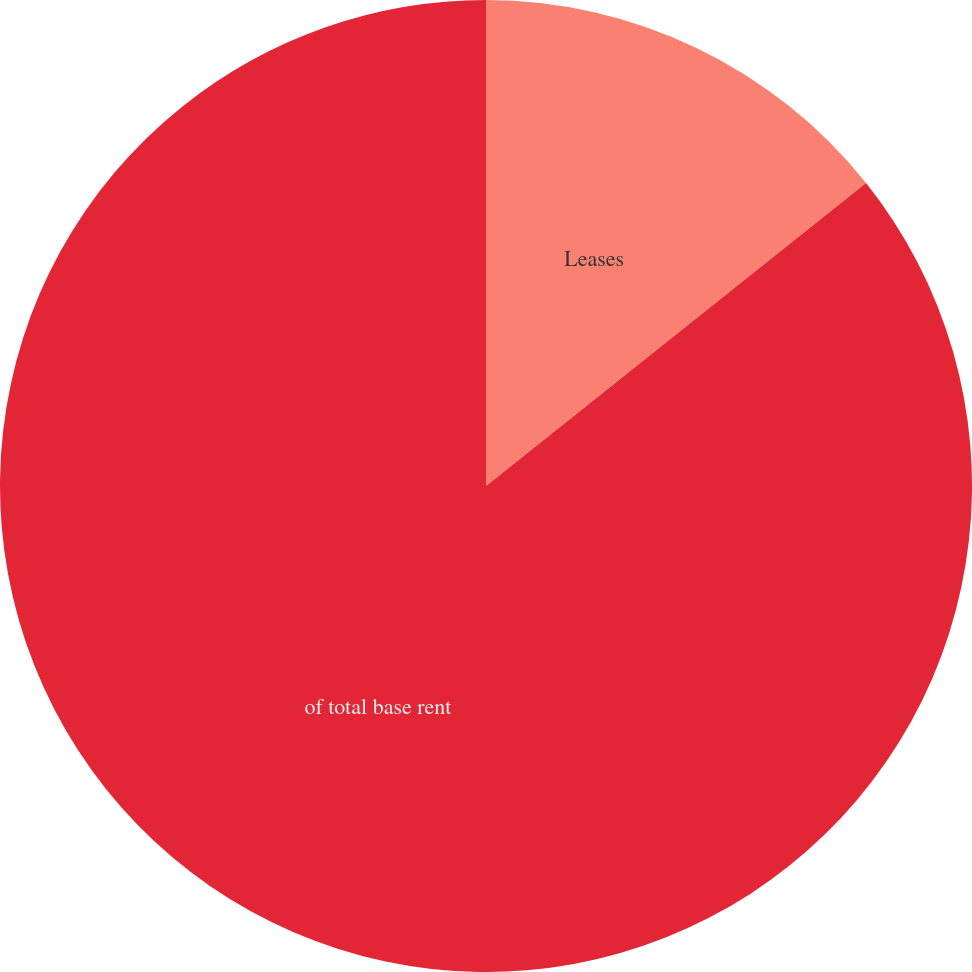Convert chart. <chart><loc_0><loc_0><loc_500><loc_500><pie_chart><fcel>Leases<fcel>of total base rent<nl><fcel>14.29%<fcel>85.71%<nl></chart> 